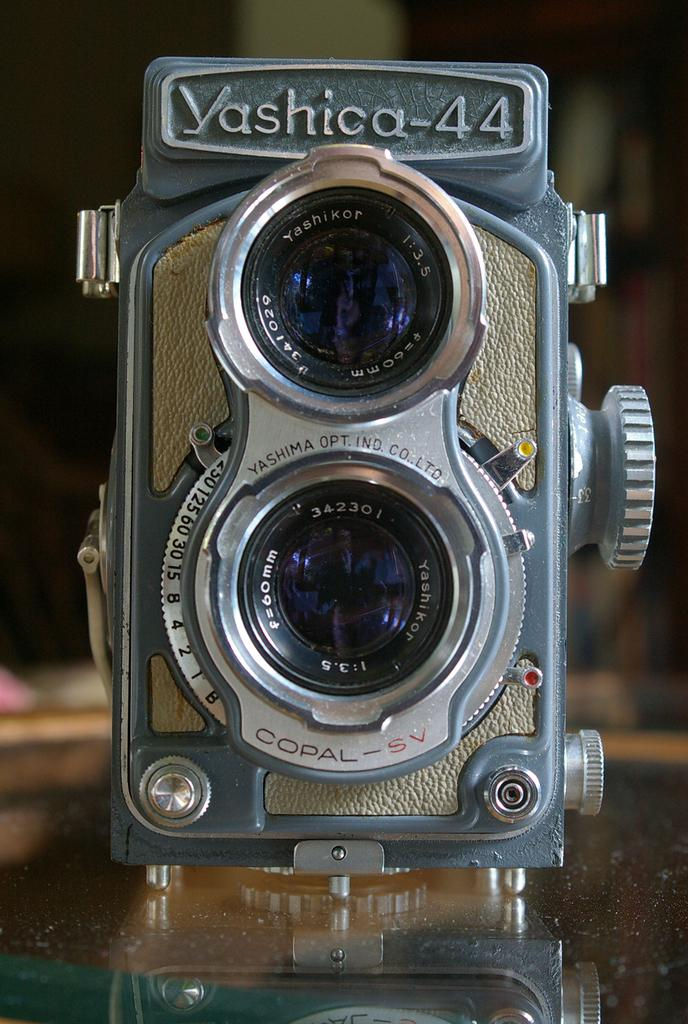What is the main object in the image? There is a camera in the image. Where is the camera placed? The camera is on a glass. Can you describe the background of the image? The background of the image is blurred. What type of drug is the camera using in the image? There is no drug present in the image, as it features a camera on a glass with a blurred background. 